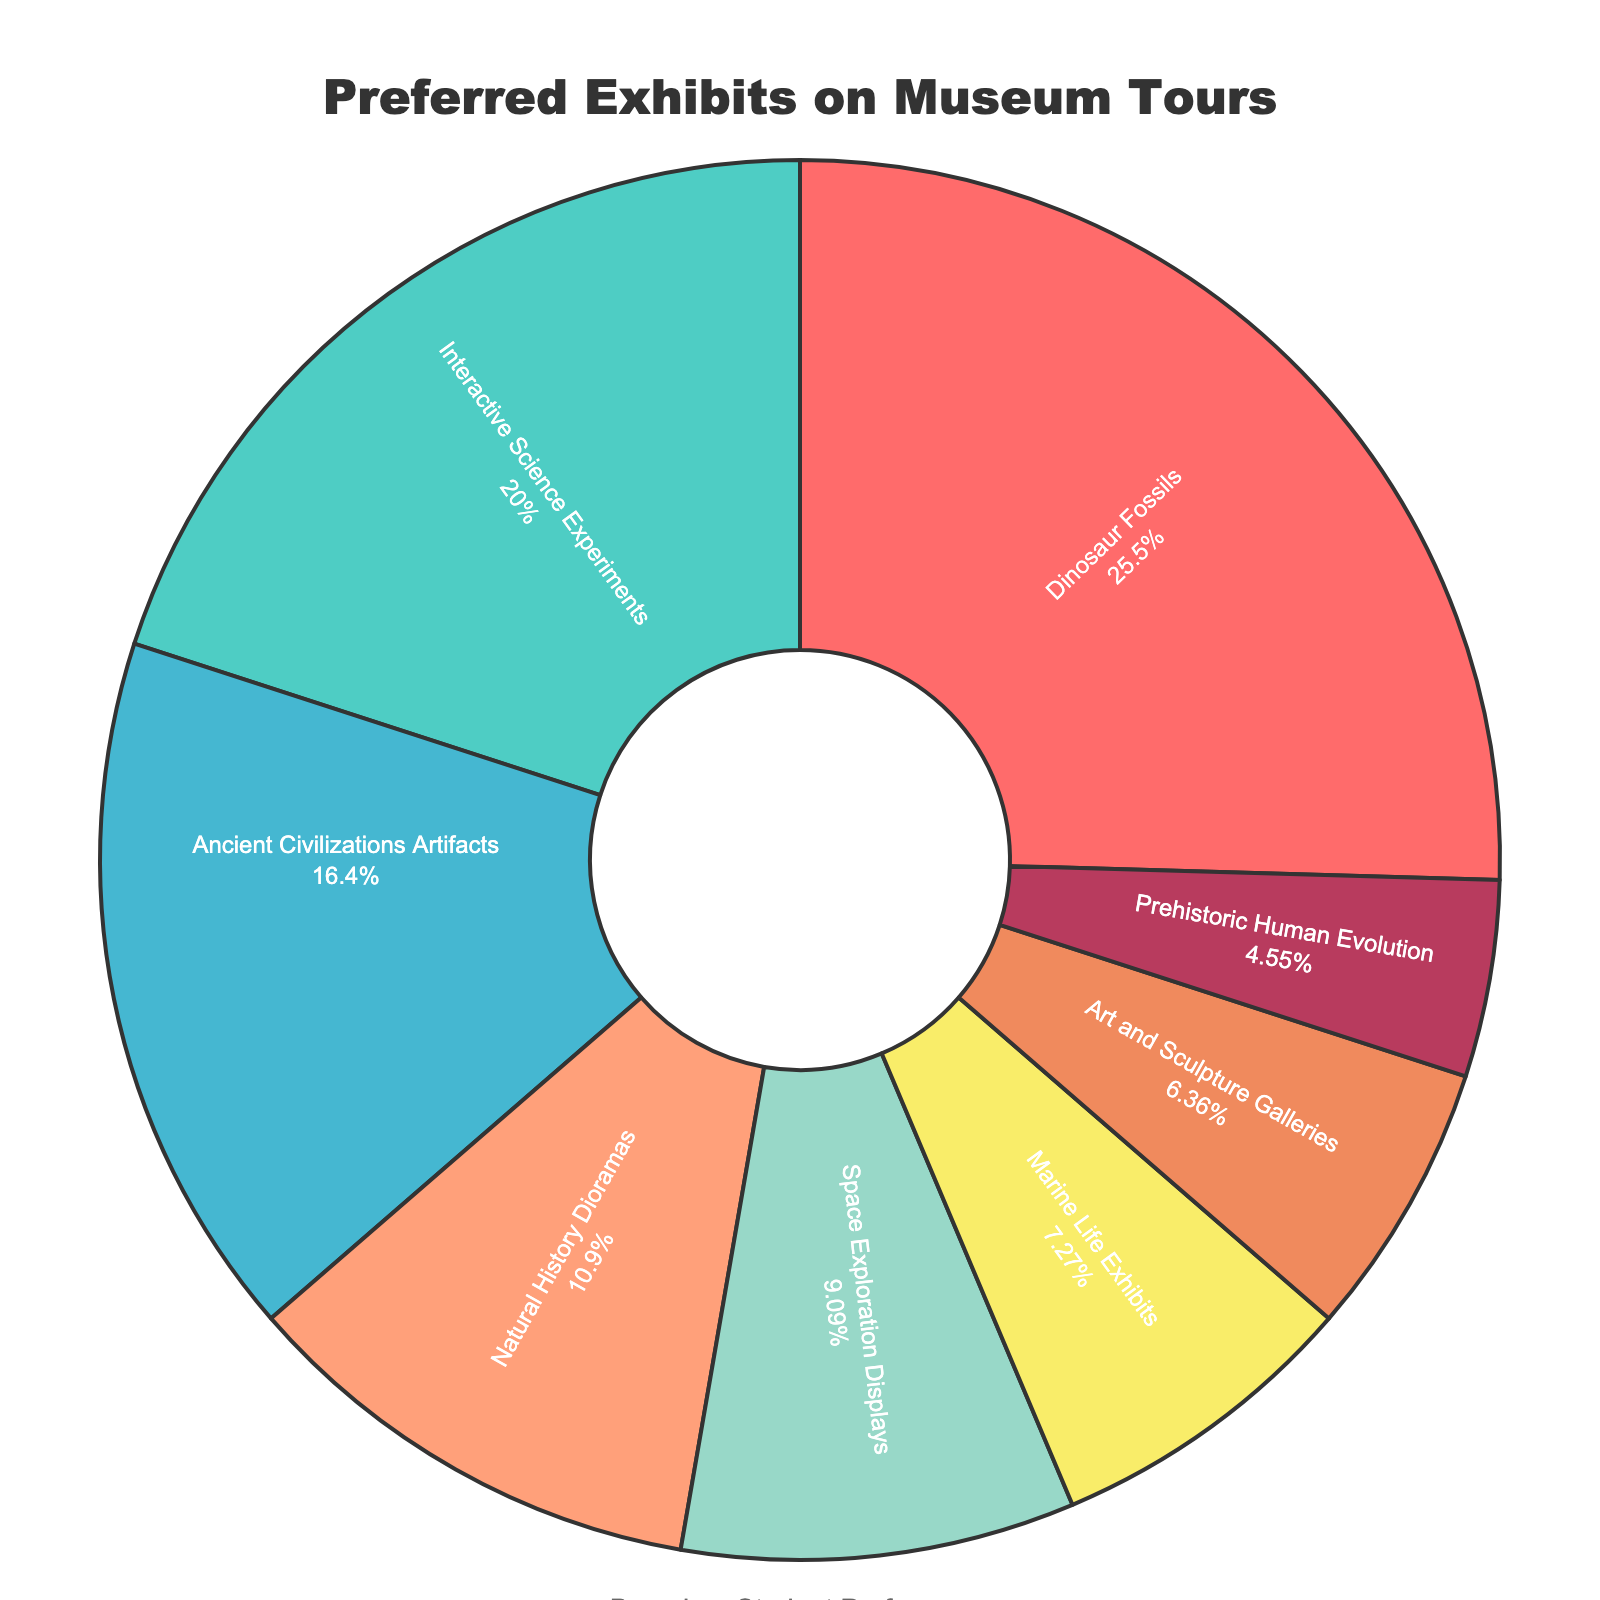What's the percentage of students who prefer Dinosaur Fossils? The pie chart shows that Dinosaur Fossils make up 28% of the exhibits preferred by students.
Answer: 28% Which exhibit type is preferred by the least percentage of students? By observing the chart, Prehistoric Human Evolution has the smallest segment, indicating it is preferred by 5% of students.
Answer: Prehistoric Human Evolution What is the combined percentage for Natural History Dioramas and Marine Life Exhibits? Looking at the segments, Natural History Dioramas have 12% and Marine Life Exhibits have 8%. Adding them together: 12% + 8% = 20%
Answer: 20% How many more students prefer Dinosaur Fossils than Prehistoric Human Evolution? Dinosaur Fossils are preferred by 28%, while Prehistoric Human Evolution is preferred by 5%. The difference is 28% - 5% = 23%.
Answer: 23% Which two exhibit types combined have the highest preference percentage? Summing up the percentages, Dinosaur Fossils (28%) and Interactive Science Experiments (22%) have the highest combined preference: 28% + 22% = 50%.
Answer: Dinosaur Fossils and Interactive Science Experiments What's the difference in preference percentage between Space Exploration Displays and Art and Sculpture Galleries? Space Exploration Displays are preferred by 10%, and Art and Sculpture Galleries are preferred by 7%. The difference is 10% - 7% = 3%.
Answer: 3% Which exhibit type is represented by the green segment? According to the colors used and the segments shown, the green segment represents Interactive Science Experiments.
Answer: Interactive Science Experiments Is the percentage of students who prefer Space Exploration Displays greater than those who prefer Ancient Civilizations Artifacts? The pie chart shows that Space Exploration Displays have 10%, while Ancient Civilizations Artifacts have 18%. Since 10% is less than 18%, the answer is no.
Answer: No Calculate the percentage of students who prefer exhibits other than Dinosaur Fossils and Interactive Science Experiments combined. Dinosaur Fossils (28%) and Interactive Science Experiments (22%) combined are 50%. So, the percentage of students who prefer other exhibits is 100% - 50% = 50%.
Answer: 50% 